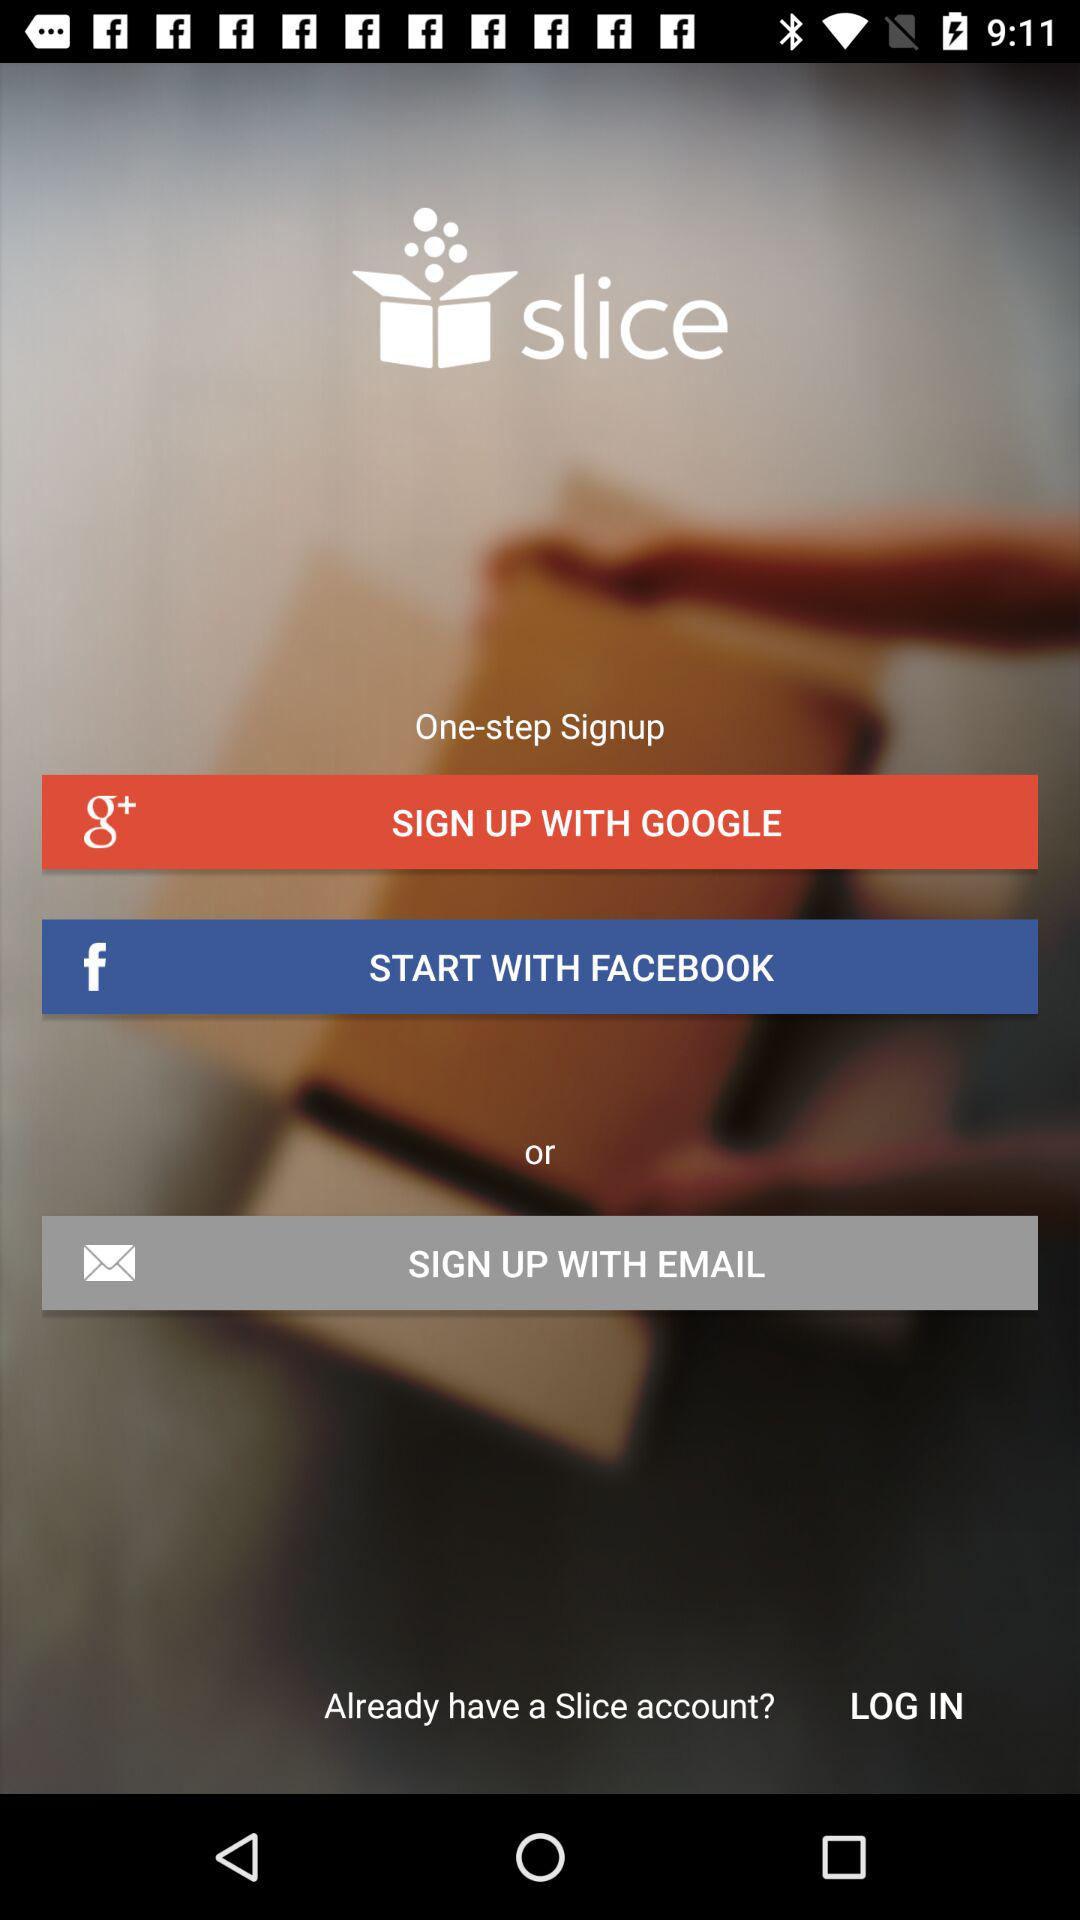Through which accounts can sign up be done? Sign up can be done through a "GOOGLE", "FACEBOOK" or "EMAIL" account. 